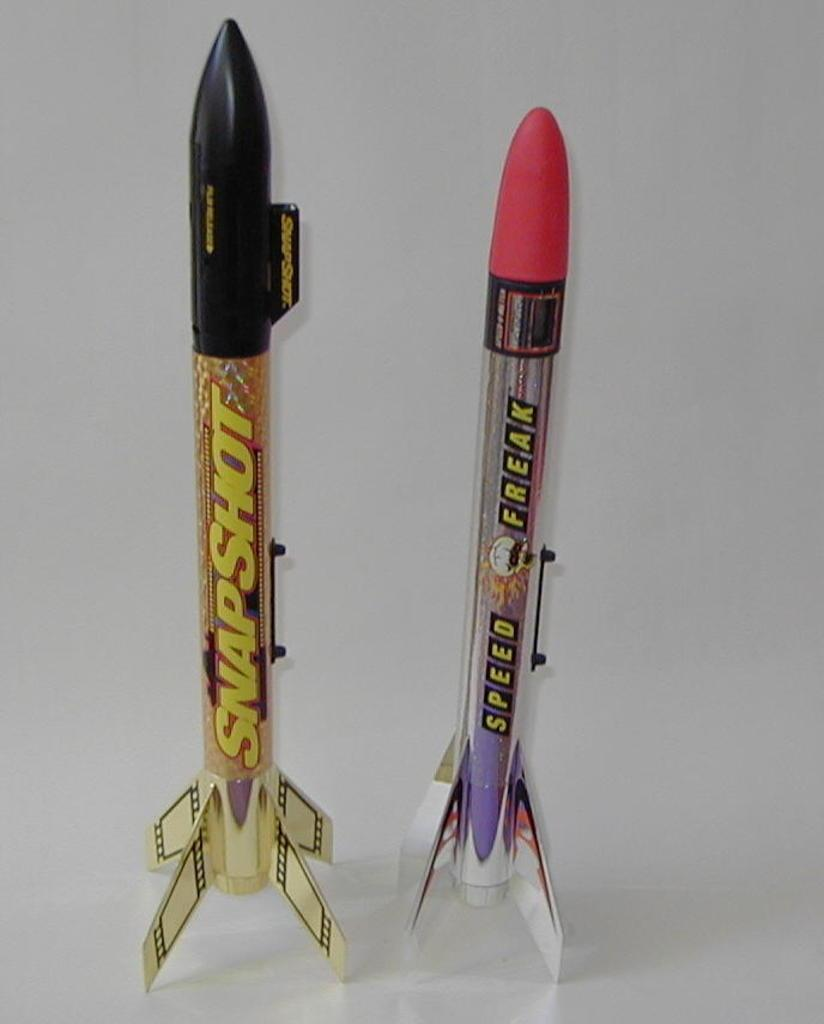What type of writing instruments are visible in the image? There are top pens in the image. What can be seen in the background of the image? There is a wall in the background of the image. What advice is being given during the meeting in the image? There is no meeting or advice present in the image; it only features top pens and a wall in the background. 